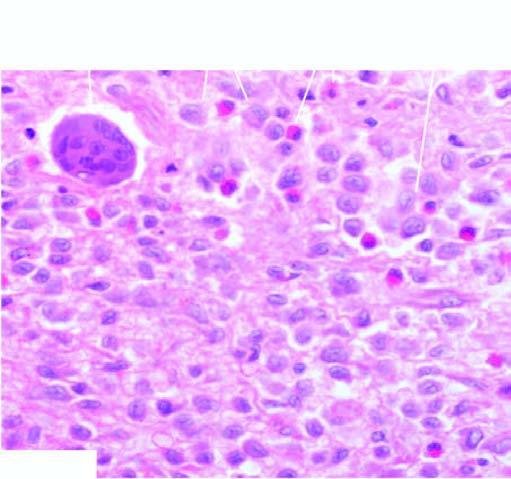what shows presence of infiltrate by collections of histiocytes having vesicular nuclei admixed with eosinophils?
Answer the question using a single word or phrase. Bone biopsy 